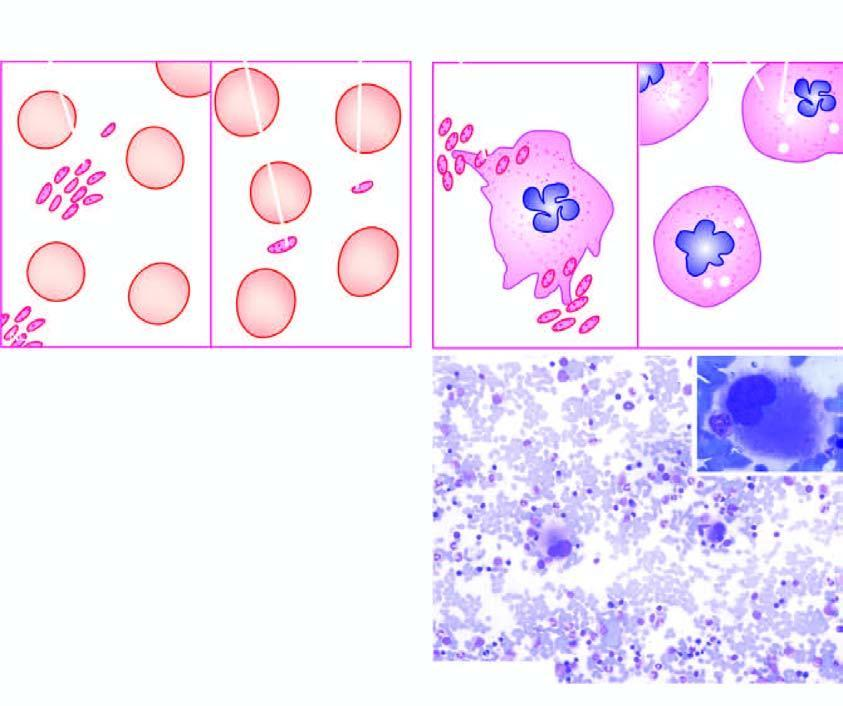what shows characteristically increased number of megakaryocytes with single non-lobulated nuclei and reduced cytoplasmic granularity inbox on right photomicrograph?
Answer the question using a single word or phrase. Bone marrow in itp 